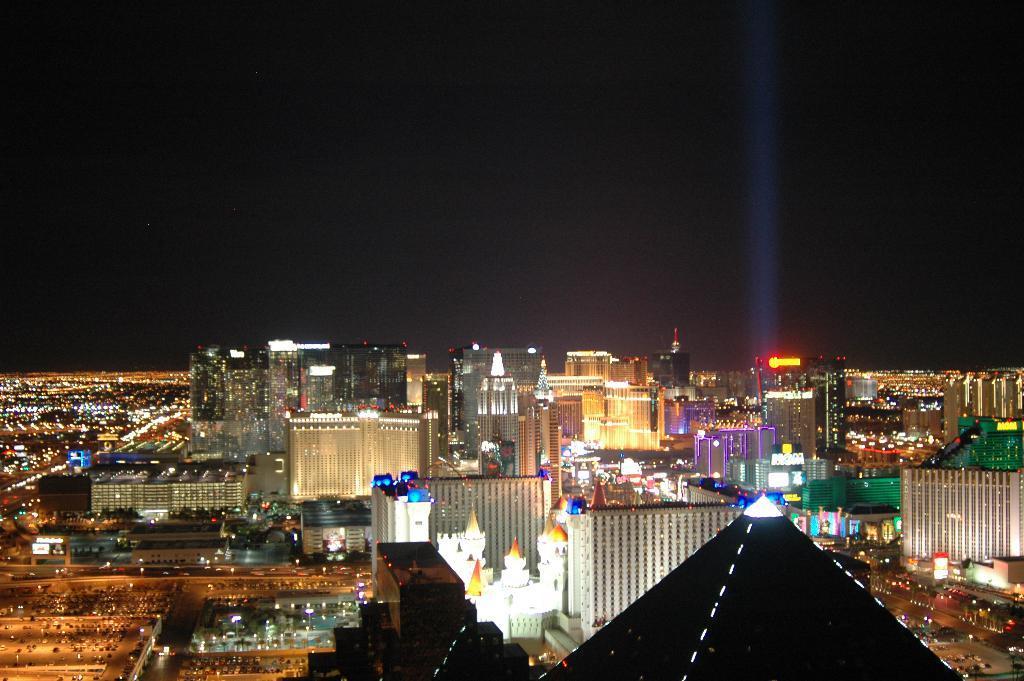Could you give a brief overview of what you see in this image? In this image, I can see the view of a city. These are the buildings with the lights. I can see the roads. These look like the name boards, which are at the top of the buildings. 